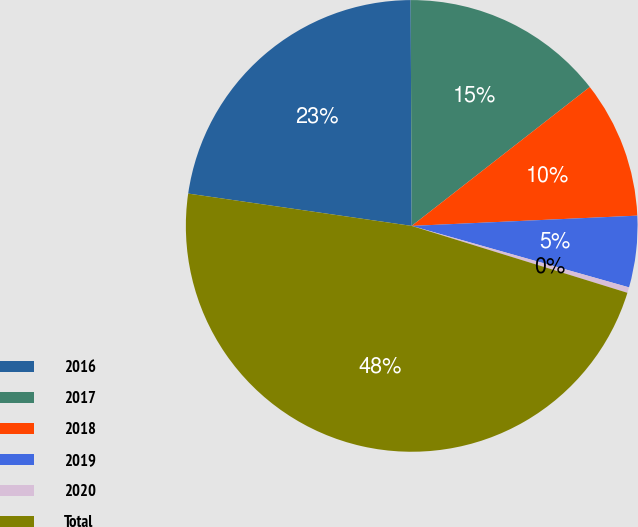<chart> <loc_0><loc_0><loc_500><loc_500><pie_chart><fcel>2016<fcel>2017<fcel>2018<fcel>2019<fcel>2020<fcel>Total<nl><fcel>22.64%<fcel>14.53%<fcel>9.82%<fcel>5.11%<fcel>0.4%<fcel>47.5%<nl></chart> 